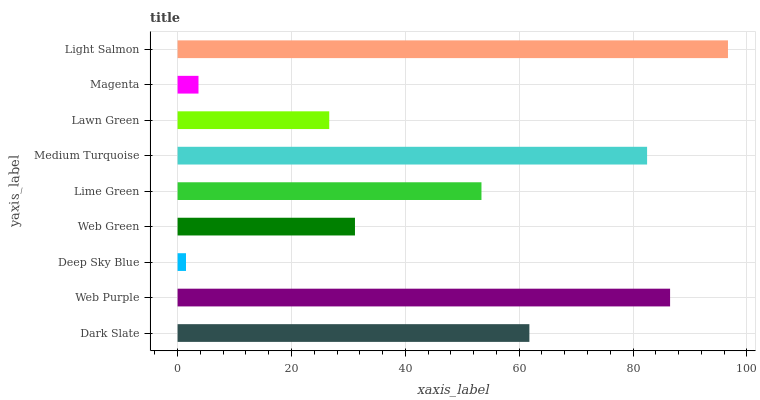Is Deep Sky Blue the minimum?
Answer yes or no. Yes. Is Light Salmon the maximum?
Answer yes or no. Yes. Is Web Purple the minimum?
Answer yes or no. No. Is Web Purple the maximum?
Answer yes or no. No. Is Web Purple greater than Dark Slate?
Answer yes or no. Yes. Is Dark Slate less than Web Purple?
Answer yes or no. Yes. Is Dark Slate greater than Web Purple?
Answer yes or no. No. Is Web Purple less than Dark Slate?
Answer yes or no. No. Is Lime Green the high median?
Answer yes or no. Yes. Is Lime Green the low median?
Answer yes or no. Yes. Is Web Purple the high median?
Answer yes or no. No. Is Lawn Green the low median?
Answer yes or no. No. 